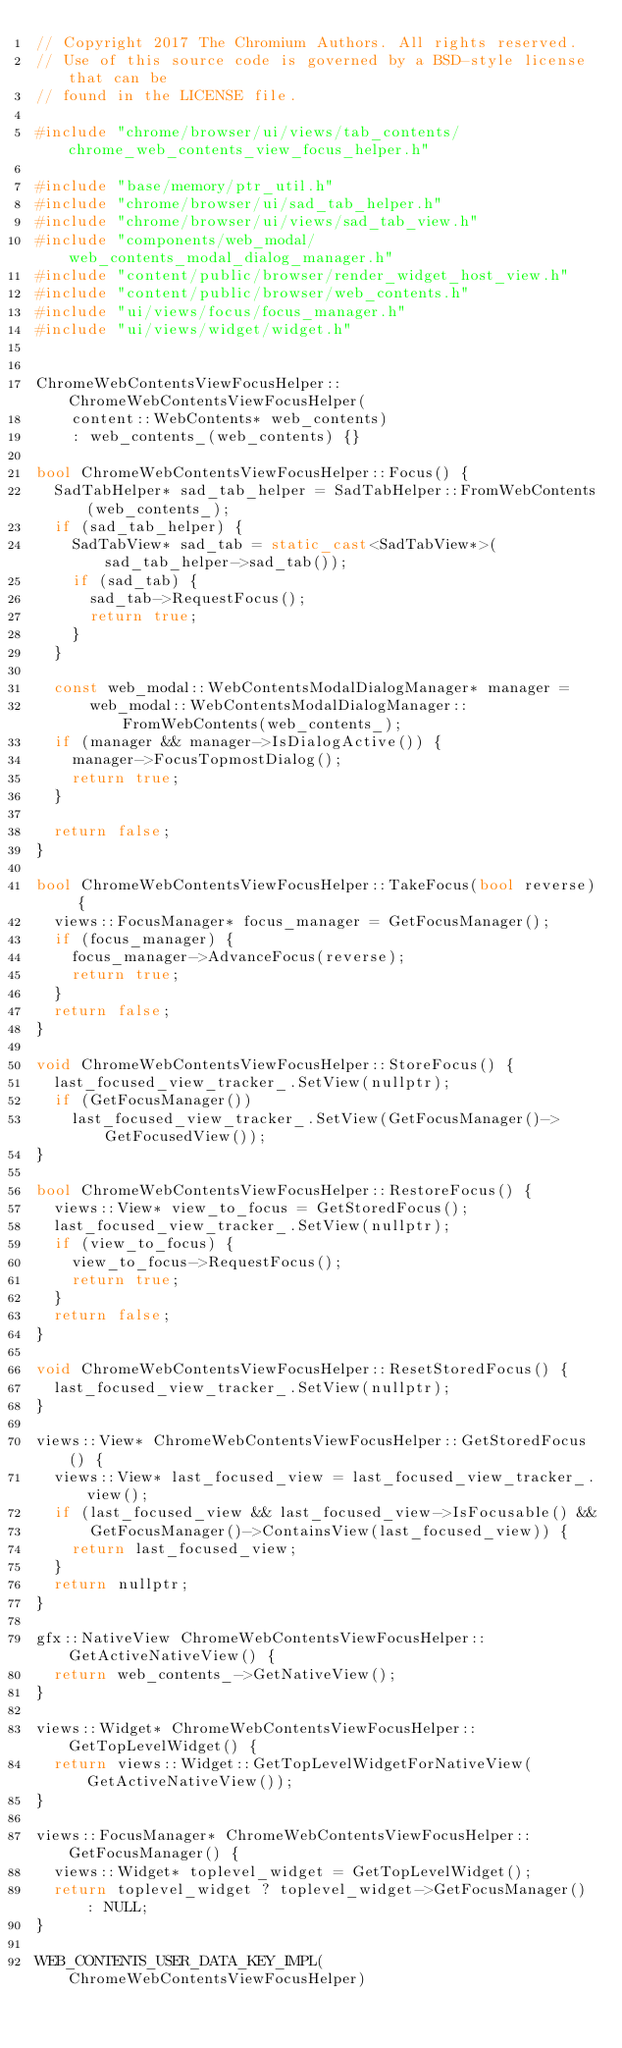<code> <loc_0><loc_0><loc_500><loc_500><_C++_>// Copyright 2017 The Chromium Authors. All rights reserved.
// Use of this source code is governed by a BSD-style license that can be
// found in the LICENSE file.

#include "chrome/browser/ui/views/tab_contents/chrome_web_contents_view_focus_helper.h"

#include "base/memory/ptr_util.h"
#include "chrome/browser/ui/sad_tab_helper.h"
#include "chrome/browser/ui/views/sad_tab_view.h"
#include "components/web_modal/web_contents_modal_dialog_manager.h"
#include "content/public/browser/render_widget_host_view.h"
#include "content/public/browser/web_contents.h"
#include "ui/views/focus/focus_manager.h"
#include "ui/views/widget/widget.h"


ChromeWebContentsViewFocusHelper::ChromeWebContentsViewFocusHelper(
    content::WebContents* web_contents)
    : web_contents_(web_contents) {}

bool ChromeWebContentsViewFocusHelper::Focus() {
  SadTabHelper* sad_tab_helper = SadTabHelper::FromWebContents(web_contents_);
  if (sad_tab_helper) {
    SadTabView* sad_tab = static_cast<SadTabView*>(sad_tab_helper->sad_tab());
    if (sad_tab) {
      sad_tab->RequestFocus();
      return true;
    }
  }

  const web_modal::WebContentsModalDialogManager* manager =
      web_modal::WebContentsModalDialogManager::FromWebContents(web_contents_);
  if (manager && manager->IsDialogActive()) {
    manager->FocusTopmostDialog();
    return true;
  }

  return false;
}

bool ChromeWebContentsViewFocusHelper::TakeFocus(bool reverse) {
  views::FocusManager* focus_manager = GetFocusManager();
  if (focus_manager) {
    focus_manager->AdvanceFocus(reverse);
    return true;
  }
  return false;
}

void ChromeWebContentsViewFocusHelper::StoreFocus() {
  last_focused_view_tracker_.SetView(nullptr);
  if (GetFocusManager())
    last_focused_view_tracker_.SetView(GetFocusManager()->GetFocusedView());
}

bool ChromeWebContentsViewFocusHelper::RestoreFocus() {
  views::View* view_to_focus = GetStoredFocus();
  last_focused_view_tracker_.SetView(nullptr);
  if (view_to_focus) {
    view_to_focus->RequestFocus();
    return true;
  }
  return false;
}

void ChromeWebContentsViewFocusHelper::ResetStoredFocus() {
  last_focused_view_tracker_.SetView(nullptr);
}

views::View* ChromeWebContentsViewFocusHelper::GetStoredFocus() {
  views::View* last_focused_view = last_focused_view_tracker_.view();
  if (last_focused_view && last_focused_view->IsFocusable() &&
      GetFocusManager()->ContainsView(last_focused_view)) {
    return last_focused_view;
  }
  return nullptr;
}

gfx::NativeView ChromeWebContentsViewFocusHelper::GetActiveNativeView() {
  return web_contents_->GetNativeView();
}

views::Widget* ChromeWebContentsViewFocusHelper::GetTopLevelWidget() {
  return views::Widget::GetTopLevelWidgetForNativeView(GetActiveNativeView());
}

views::FocusManager* ChromeWebContentsViewFocusHelper::GetFocusManager() {
  views::Widget* toplevel_widget = GetTopLevelWidget();
  return toplevel_widget ? toplevel_widget->GetFocusManager() : NULL;
}

WEB_CONTENTS_USER_DATA_KEY_IMPL(ChromeWebContentsViewFocusHelper)
</code> 